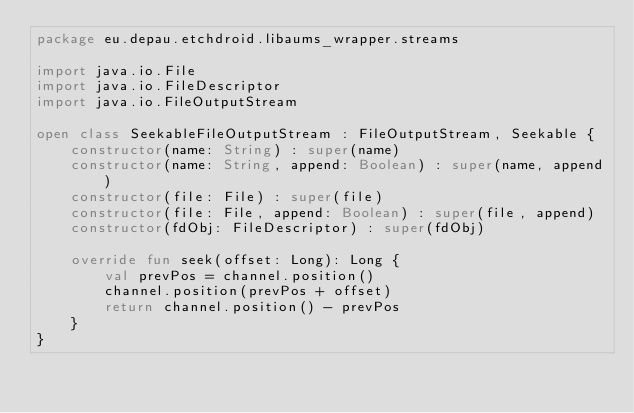<code> <loc_0><loc_0><loc_500><loc_500><_Kotlin_>package eu.depau.etchdroid.libaums_wrapper.streams

import java.io.File
import java.io.FileDescriptor
import java.io.FileOutputStream

open class SeekableFileOutputStream : FileOutputStream, Seekable {
    constructor(name: String) : super(name)
    constructor(name: String, append: Boolean) : super(name, append)
    constructor(file: File) : super(file)
    constructor(file: File, append: Boolean) : super(file, append)
    constructor(fdObj: FileDescriptor) : super(fdObj)

    override fun seek(offset: Long): Long {
        val prevPos = channel.position()
        channel.position(prevPos + offset)
        return channel.position() - prevPos
    }
}</code> 